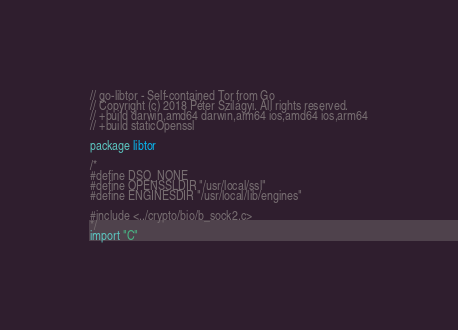<code> <loc_0><loc_0><loc_500><loc_500><_Go_>// go-libtor - Self-contained Tor from Go
// Copyright (c) 2018 Péter Szilágyi. All rights reserved.
// +build darwin,amd64 darwin,arm64 ios,amd64 ios,arm64
// +build staticOpenssl

package libtor

/*
#define DSO_NONE
#define OPENSSLDIR "/usr/local/ssl"
#define ENGINESDIR "/usr/local/lib/engines"

#include <../crypto/bio/b_sock2.c>
*/
import "C"
</code> 